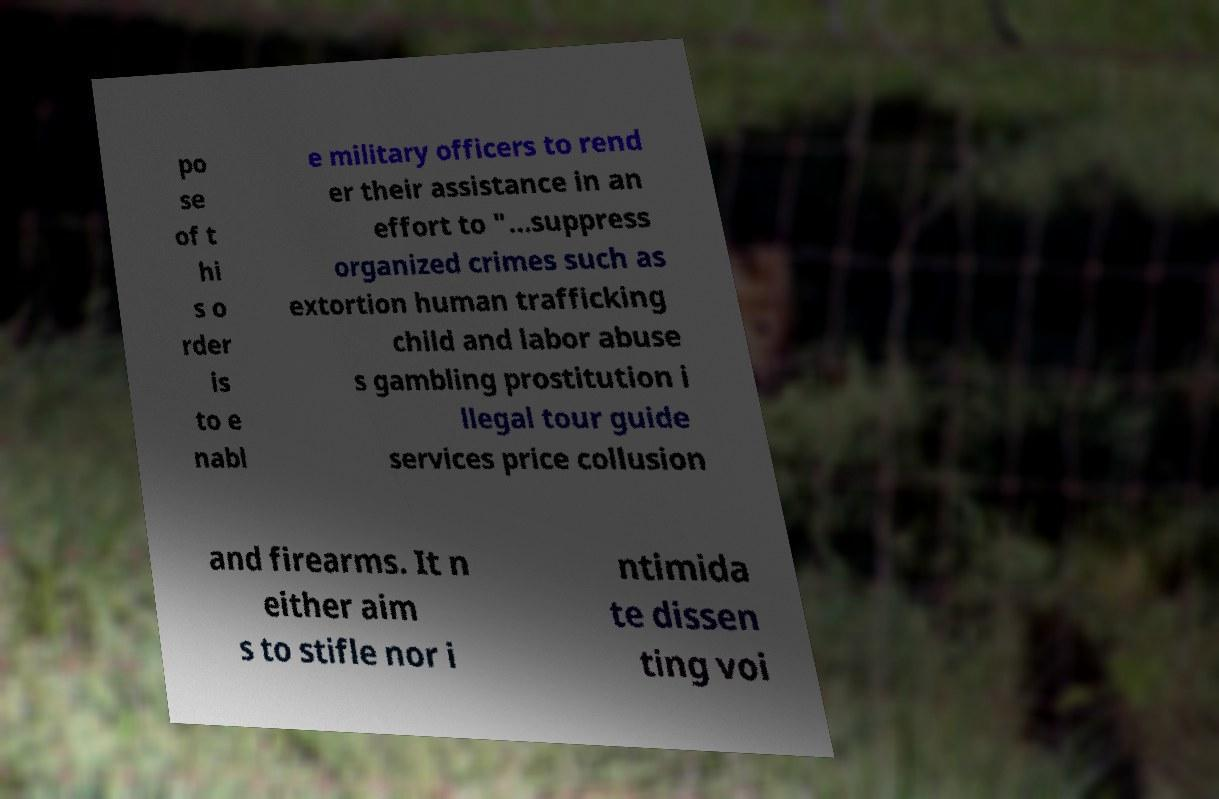There's text embedded in this image that I need extracted. Can you transcribe it verbatim? po se of t hi s o rder is to e nabl e military officers to rend er their assistance in an effort to "...suppress organized crimes such as extortion human trafficking child and labor abuse s gambling prostitution i llegal tour guide services price collusion and firearms. It n either aim s to stifle nor i ntimida te dissen ting voi 